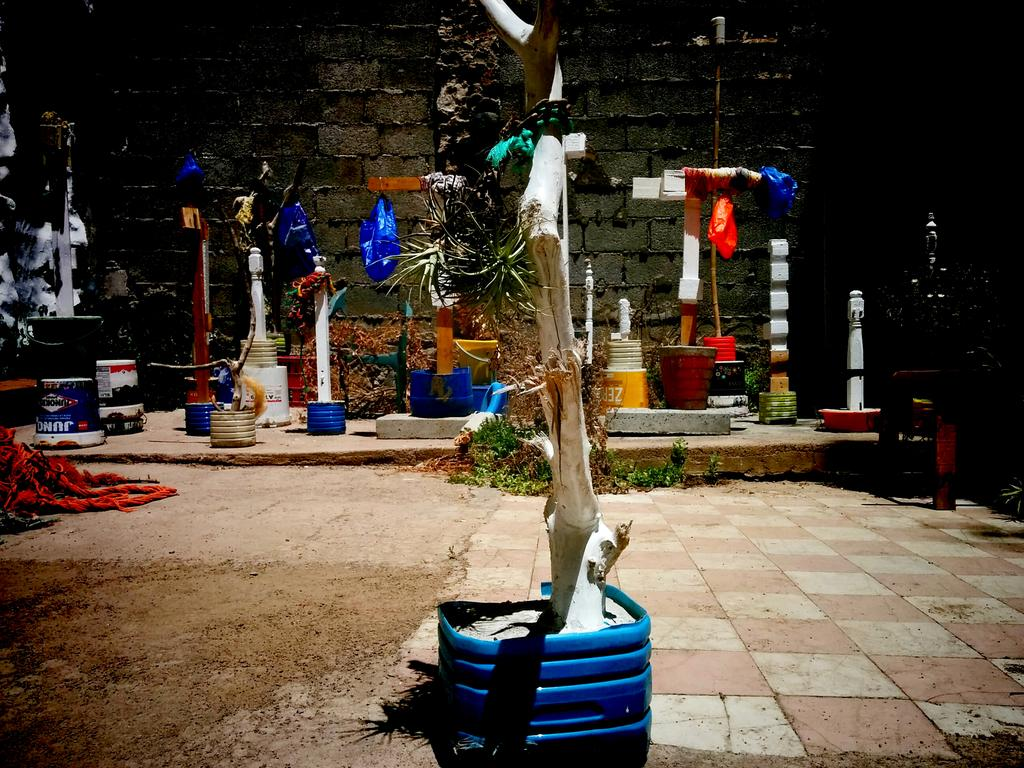What is the main subject in the center of the image? There is a tree in the center of the image. How is the tree positioned in the image? The tree is in a blue color tub. What can be seen in the background of the image? There are a few objects and a wall in the background of the image. Reasoning: Let' Let's think step by step in order to produce the conversation. We start by identifying the main subject in the image, which is the tree. Then, we describe the unique feature of the tree, which is its position in a blue color tub. Finally, we mention the background elements, including the presence of objects and a wall. Each question is designed to elicit a specific detail about the image that is known from the provided facts. Absurd Question/Answer: What type of verse is being recited by the tree in the image? There is no verse being recited by the tree in the image, as trees do not have the ability to recite verses. 